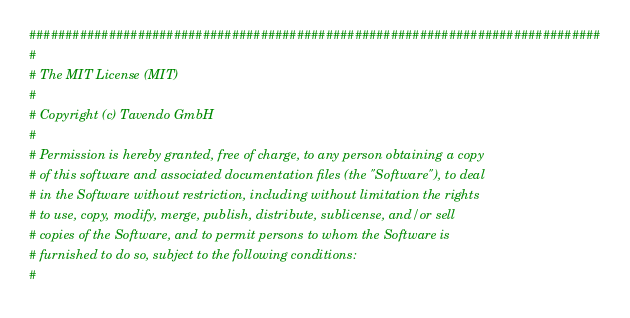Convert code to text. <code><loc_0><loc_0><loc_500><loc_500><_Python_>###############################################################################
#
# The MIT License (MIT)
#
# Copyright (c) Tavendo GmbH
#
# Permission is hereby granted, free of charge, to any person obtaining a copy
# of this software and associated documentation files (the "Software"), to deal
# in the Software without restriction, including without limitation the rights
# to use, copy, modify, merge, publish, distribute, sublicense, and/or sell
# copies of the Software, and to permit persons to whom the Software is
# furnished to do so, subject to the following conditions:
#</code> 